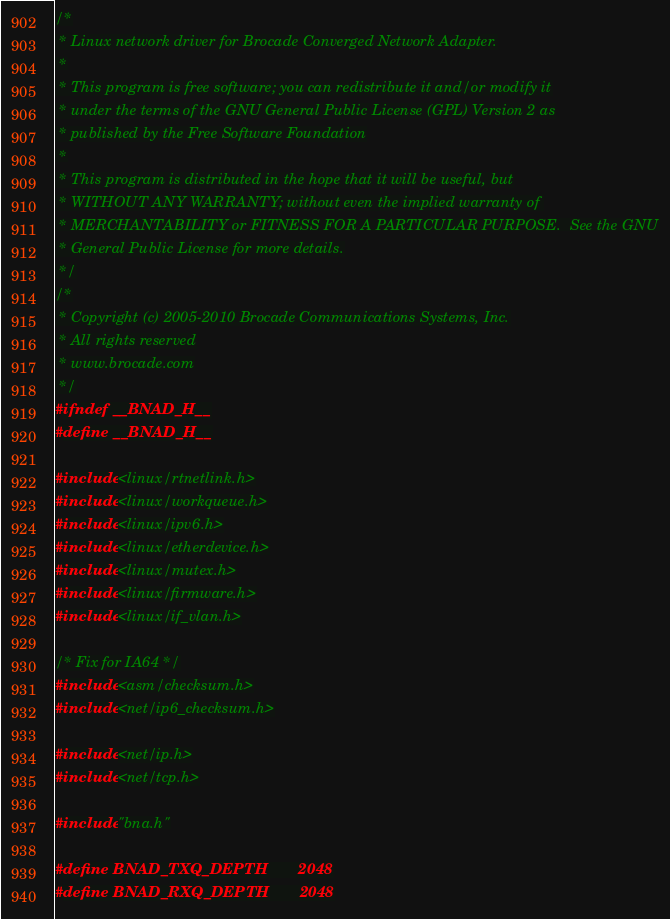<code> <loc_0><loc_0><loc_500><loc_500><_C_>/*
 * Linux network driver for Brocade Converged Network Adapter.
 *
 * This program is free software; you can redistribute it and/or modify it
 * under the terms of the GNU General Public License (GPL) Version 2 as
 * published by the Free Software Foundation
 *
 * This program is distributed in the hope that it will be useful, but
 * WITHOUT ANY WARRANTY; without even the implied warranty of
 * MERCHANTABILITY or FITNESS FOR A PARTICULAR PURPOSE.  See the GNU
 * General Public License for more details.
 */
/*
 * Copyright (c) 2005-2010 Brocade Communications Systems, Inc.
 * All rights reserved
 * www.brocade.com
 */
#ifndef __BNAD_H__
#define __BNAD_H__

#include <linux/rtnetlink.h>
#include <linux/workqueue.h>
#include <linux/ipv6.h>
#include <linux/etherdevice.h>
#include <linux/mutex.h>
#include <linux/firmware.h>
#include <linux/if_vlan.h>

/* Fix for IA64 */
#include <asm/checksum.h>
#include <net/ip6_checksum.h>

#include <net/ip.h>
#include <net/tcp.h>

#include "bna.h"

#define BNAD_TXQ_DEPTH		2048
#define BNAD_RXQ_DEPTH		2048
</code> 